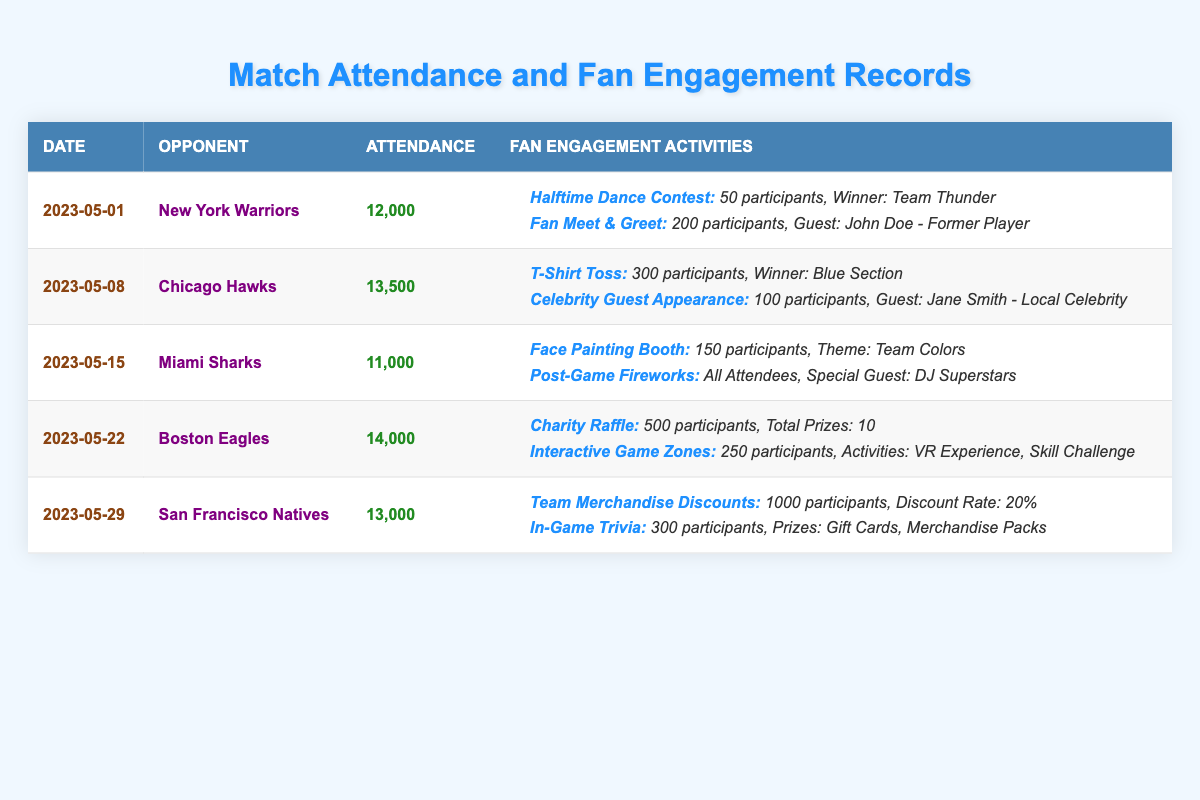What was the attendance for the match against the Boston Eagles? According to the table, the attendance for the match on 2023-05-22 against the Boston Eagles was listed as 14,000.
Answer: 14,000 Which fan engagement activity had the highest number of participants? By examining the participant numbers across all activities, the Charity Raffle for the Boston Eagles match had 500 participants, which is the highest compared to other activities.
Answer: Charity Raffle Was there a fan engagement activity with a special guest? Yes, the Post-Game Fireworks during the match against the Miami Sharks featured DJ Superstars as a special guest.
Answer: Yes What is the average attendance over all matches? To calculate the average attendance, sum the attendance values: 12,000 + 13,500 + 11,000 + 14,000 + 13,000 = 63,500. Then, divide this total by the number of matches (5), resulting in an average of 63,500 ÷ 5 = 12,700.
Answer: 12,700 Did the San Francisco Natives game have more than 1,000 participants in fan engagement activities? Yes, if you add the participants from Team Merchandise Discounts (1,000) and In-Game Trivia (300), the total number of participants is 1,000 + 300 = 1,300, which is indeed more than 1,000.
Answer: Yes How many matches had an attendance of more than 13,000? The matches against Chicago Hawks (13,500), Boston Eagles (14,000), and San Francisco Natives (13,000) all had attendance figures above 13,000. This makes a total of three matches.
Answer: 3 In which match did the Face Painting Booth take place, and how many participants were there? The Face Painting Booth was part of the engagement activities during the match against the Miami Sharks on 2023-05-15, and it had 150 participants.
Answer: Miami Sharks, 150 What was the total number of participants across all fan engagement activities for the match against New York Warriors? For the match on 2023-05-01, the Halftime Dance Contest had 50 participants and the Fan Meet & Greet had 200 participants. Summing these gives 50 + 200 = 250 participants in total.
Answer: 250 Which activity involved a theme, and what was it? The Face Painting Booth during the Miami Sharks match had a theme, which was the team colors.
Answer: Team Colors 